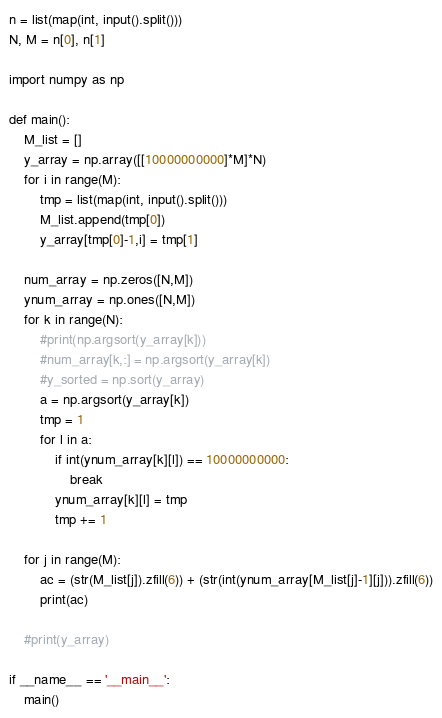Convert code to text. <code><loc_0><loc_0><loc_500><loc_500><_Python_>n = list(map(int, input().split()))
N, M = n[0], n[1]

import numpy as np

def main():
    M_list = []
    y_array = np.array([[10000000000]*M]*N)
    for i in range(M):
        tmp = list(map(int, input().split()))
        M_list.append(tmp[0])
        y_array[tmp[0]-1,i] = tmp[1]

    num_array = np.zeros([N,M])
    ynum_array = np.ones([N,M])
    for k in range(N):
        #print(np.argsort(y_array[k]))
        #num_array[k,:] = np.argsort(y_array[k])
        #y_sorted = np.sort(y_array)
        a = np.argsort(y_array[k])
        tmp = 1
        for l in a:
            if int(ynum_array[k][l]) == 10000000000:
                break
            ynum_array[k][l] = tmp
            tmp += 1

    for j in range(M):
        ac = (str(M_list[j]).zfill(6)) + (str(int(ynum_array[M_list[j]-1][j])).zfill(6))
        print(ac)
        
    #print(y_array)

if __name__ == '__main__':
    main()


</code> 